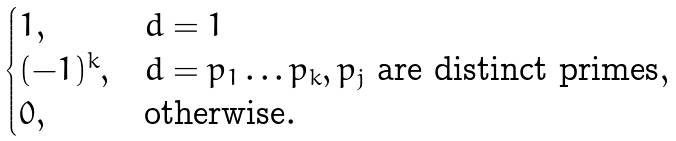Convert formula to latex. <formula><loc_0><loc_0><loc_500><loc_500>\begin{cases} 1 , & d = 1 \\ ( - 1 ) ^ { k } , & d = p _ { 1 } \dots p _ { k } , p _ { j } \text { are distinct primes} , \\ 0 , & \text {otherwise} . \end{cases}</formula> 